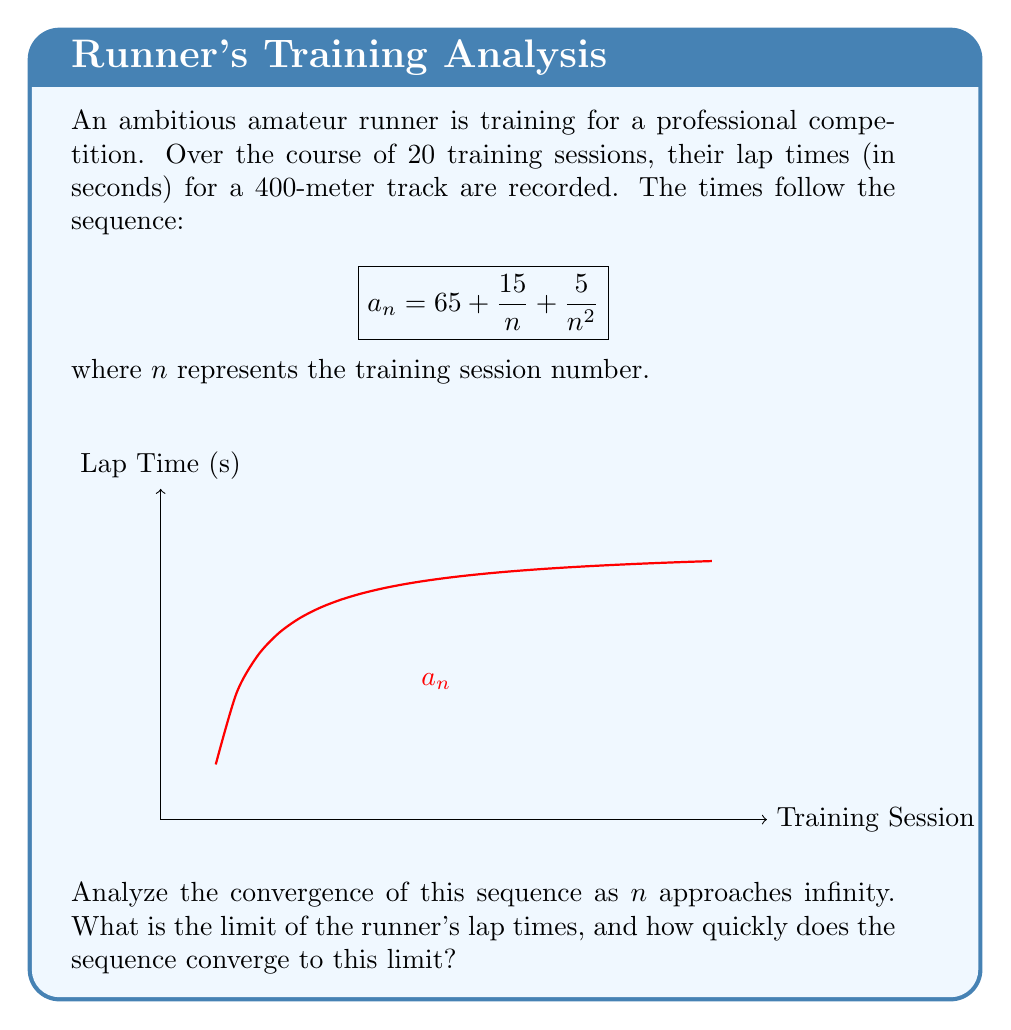Could you help me with this problem? To analyze the convergence of this sequence, we'll follow these steps:

1) First, let's examine the limit of $a_n$ as $n$ approaches infinity:

   $$\lim_{n \to \infty} a_n = \lim_{n \to \infty} \left(65 + \frac{15}{n} + \frac{5}{n^2}\right)$$

2) As $n$ approaches infinity, $\frac{1}{n}$ and $\frac{1}{n^2}$ both approach 0:

   $$\lim_{n \to \infty} a_n = 65 + 0 + 0 = 65$$

3) This means the sequence converges to 65 seconds.

4) To determine the rate of convergence, we can look at the difference between $a_n$ and the limit:

   $$a_n - 65 = \frac{15}{n} + \frac{5}{n^2}$$

5) This difference is of the order $O(\frac{1}{n})$, which means the sequence converges linearly to 65.

6) We can also estimate how many training sessions it might take to get within 1 second of the limit:

   $$\frac{15}{n} + \frac{5}{n^2} < 1$$

   Solving this inequality (approximately) gives $n > 16$.

Therefore, the runner's lap times converge to 65 seconds at a linear rate, and they can expect to be within 1 second of this limit after about 16 training sessions.
Answer: The sequence converges to 65 seconds at a linear rate $O(\frac{1}{n})$. 